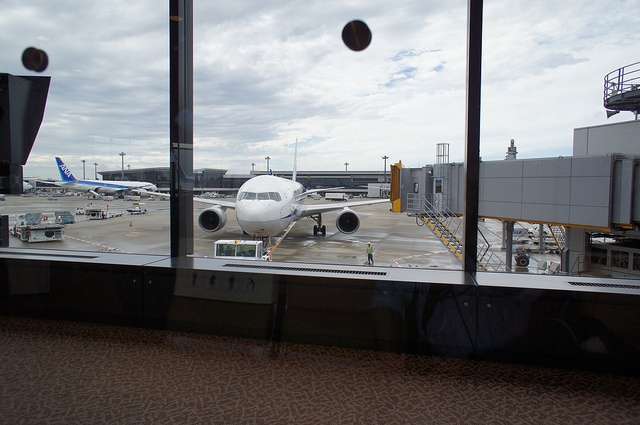Describe the objects in this image and their specific colors. I can see airplane in darkgray, lightgray, gray, and black tones, airplane in darkgray, gray, and lightgray tones, truck in darkgray, gray, lightgray, and black tones, truck in darkgray, gray, black, and lightgray tones, and people in darkgray, gray, and black tones in this image. 